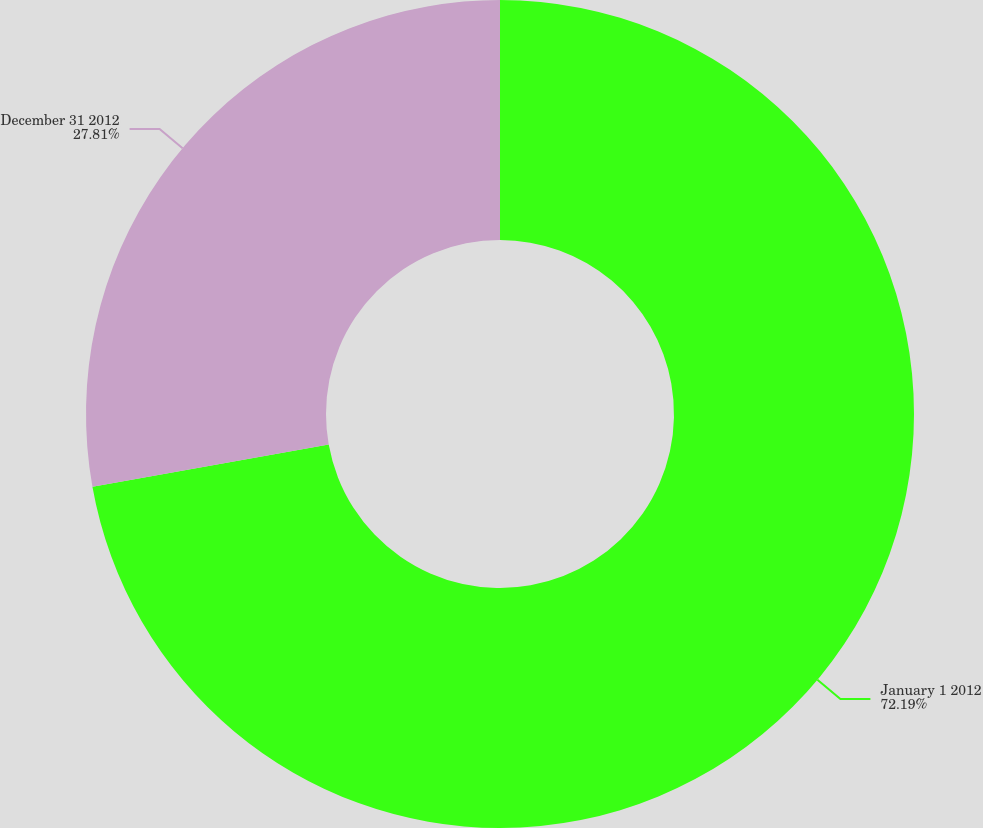<chart> <loc_0><loc_0><loc_500><loc_500><pie_chart><fcel>January 1 2012<fcel>December 31 2012<nl><fcel>72.19%<fcel>27.81%<nl></chart> 